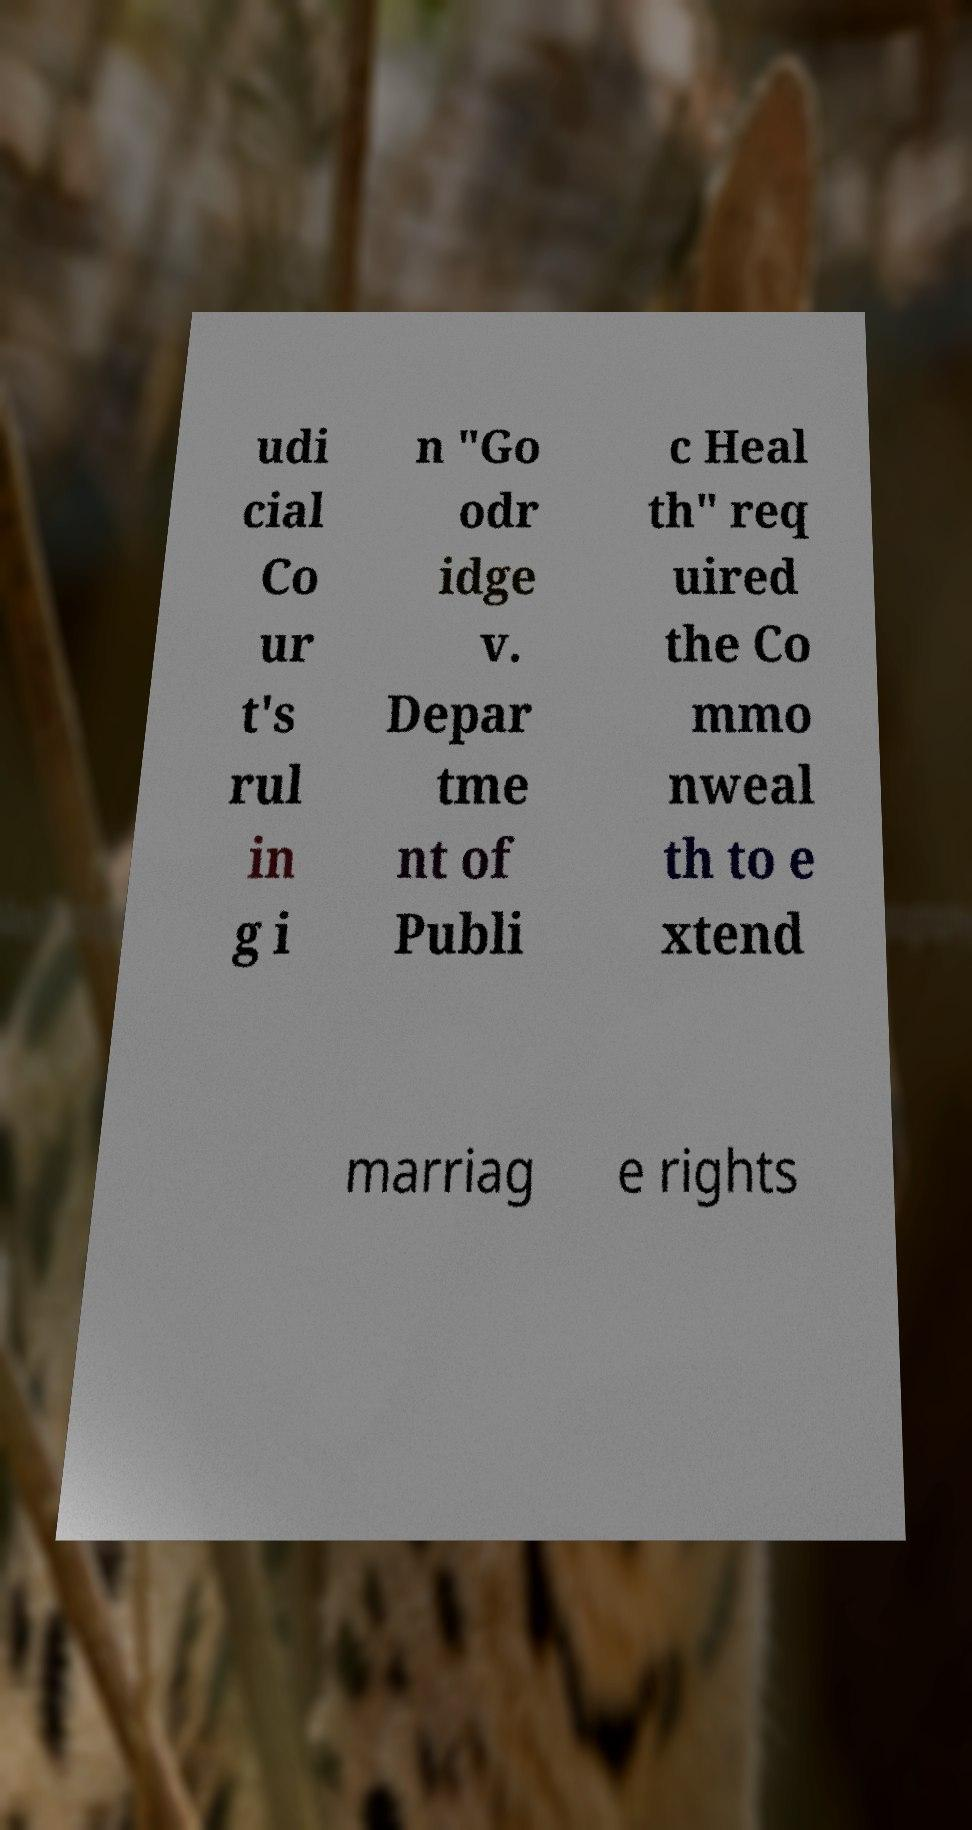Could you assist in decoding the text presented in this image and type it out clearly? udi cial Co ur t's rul in g i n "Go odr idge v. Depar tme nt of Publi c Heal th" req uired the Co mmo nweal th to e xtend marriag e rights 